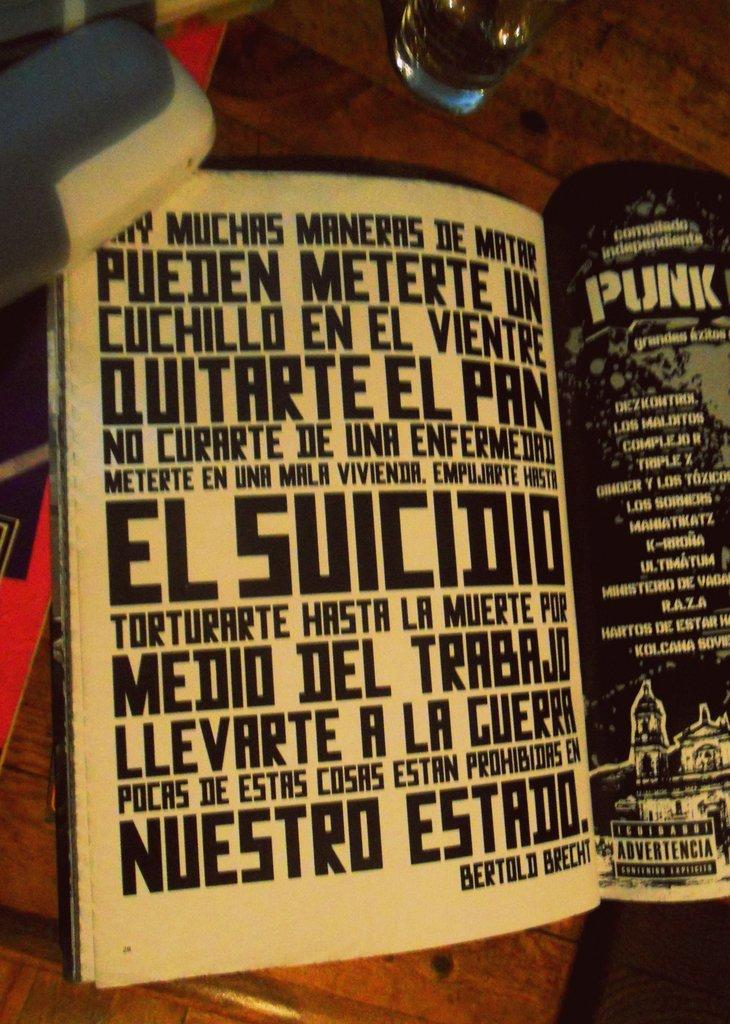<image>
Present a compact description of the photo's key features. A magazine is open to two pages, the word Punk visible on the right page. 